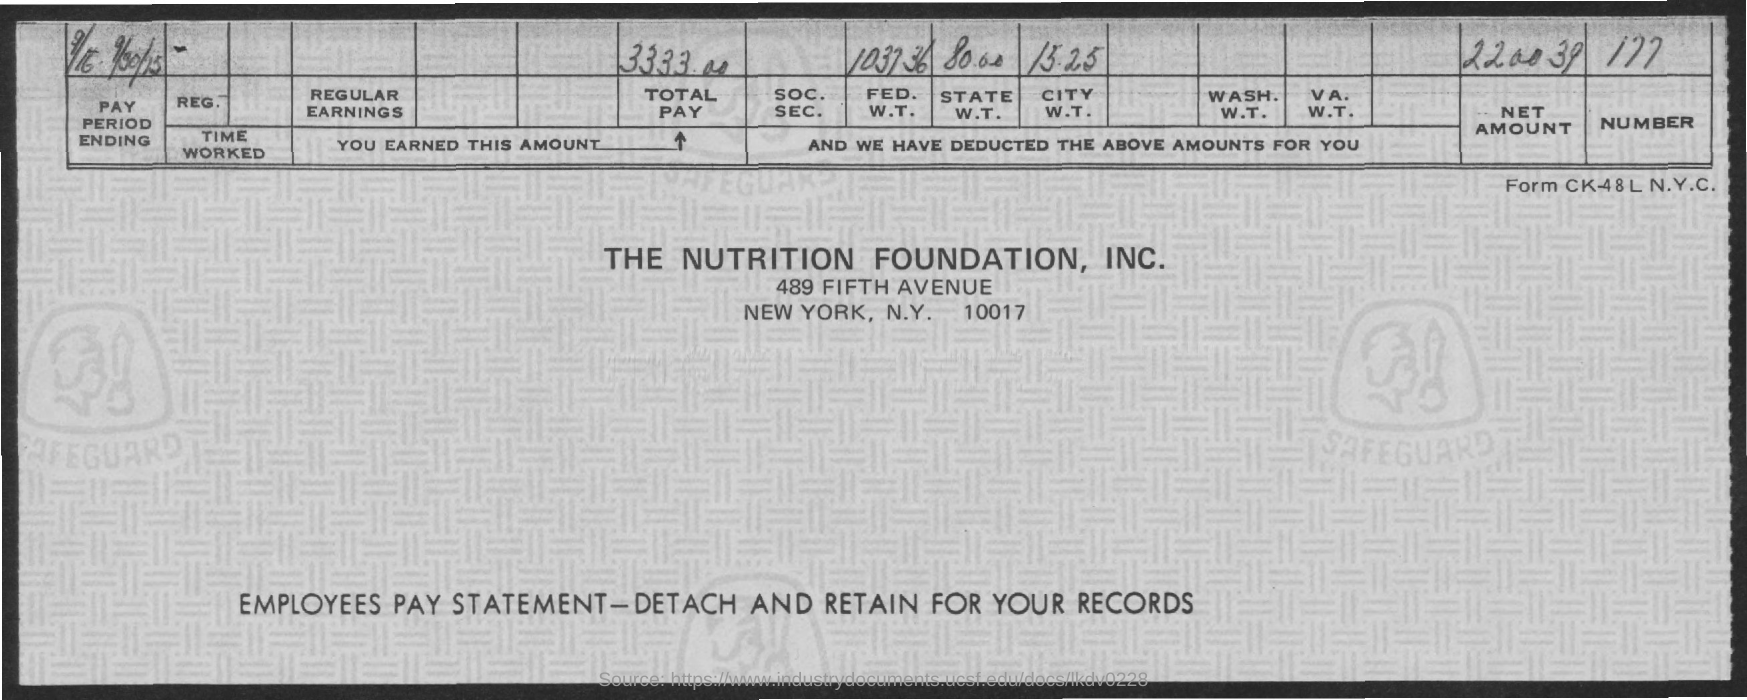Specify some key components in this picture. The total pay is 3333.00. The net amount specified is 220039. 